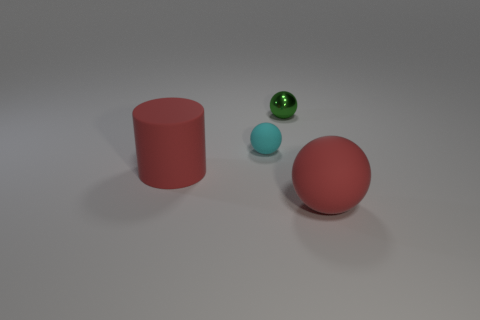Can you compare the textures of the objects shown in the image? Certainly, the image presents a variety of textures. The red rubber sphere on the left exhibits a matte finish that diffuses light softly. The cyan ball displays a similarly matte texture, albeit with a lighter shade that implies a different material composition. In contrast, the green metallic object possesses a reflective surface that creates a glossy appearance, accentuating its smooth curvature. 